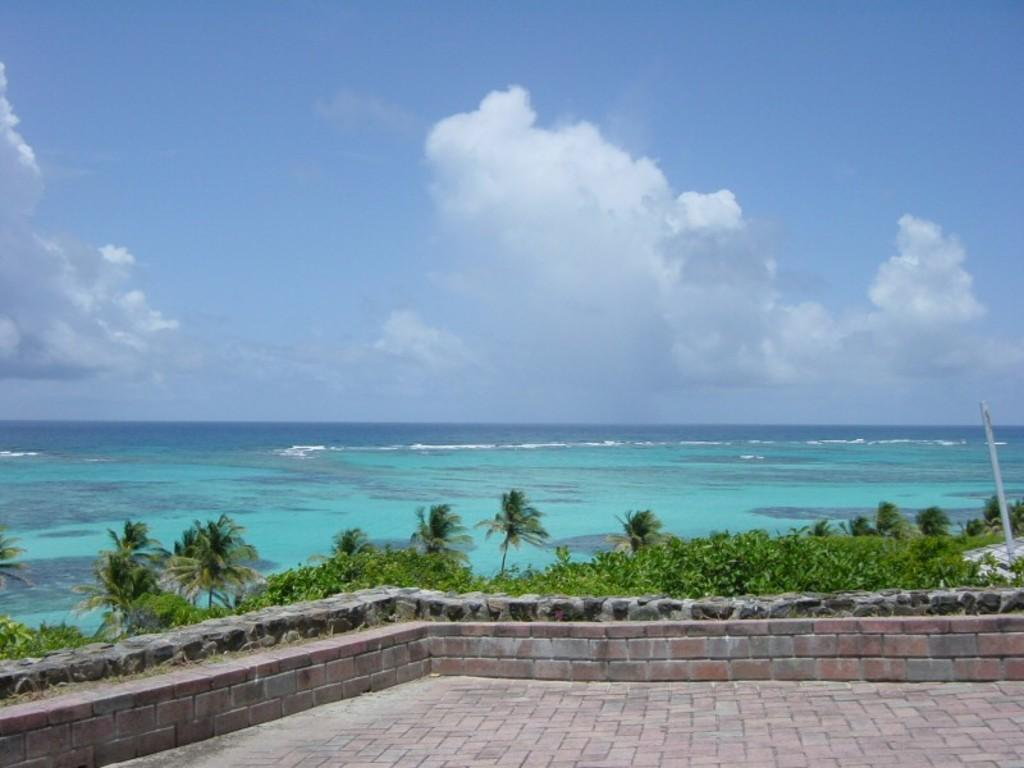What can be seen in the sky in the image? The sky with clouds is visible in the image. What type of natural body of water is present in the image? There is sea visible in the image. What type of vegetation is present in the image? Coconut trees are present in the image. What type of structures can be seen in the image? There are poles in the image. What type of surface is visible in the image? Pavement is visible in the image. What type of flooring is present in the image? There is a floor in the image. What type of range is visible in the image? There is no range present in the image. How many yards are visible in the image? There is no yard present in the image. 